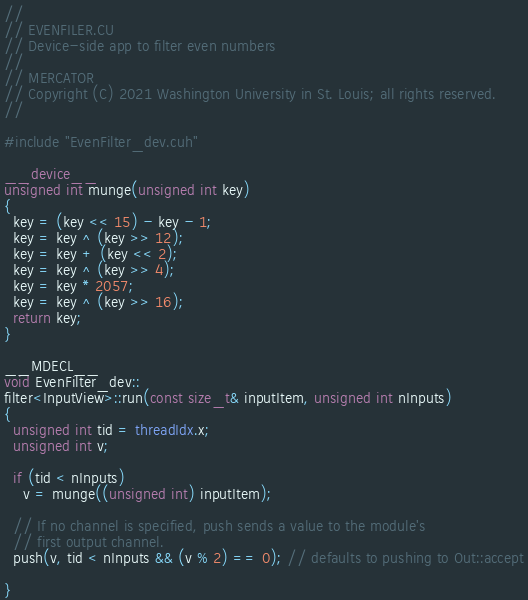Convert code to text. <code><loc_0><loc_0><loc_500><loc_500><_Cuda_>//
// EVENFILER.CU
// Device-side app to filter even numbers
//
// MERCATOR
// Copyright (C) 2021 Washington University in St. Louis; all rights reserved.
//

#include "EvenFilter_dev.cuh"

__device__
unsigned int munge(unsigned int key)
{
  key = (key << 15) - key - 1;
  key = key ^ (key >> 12);
  key = key + (key << 2);
  key = key ^ (key >> 4);
  key = key * 2057;
  key = key ^ (key >> 16);
  return key;
}

__MDECL__
void EvenFilter_dev::
filter<InputView>::run(const size_t& inputItem, unsigned int nInputs)
{
  unsigned int tid = threadIdx.x;
  unsigned int v;
  
  if (tid < nInputs)
    v = munge((unsigned int) inputItem);
  
  // If no channel is specified, push sends a value to the module's
  // first output channel.
  push(v, tid < nInputs && (v % 2) == 0); // defaults to pushing to Out::accept

}

</code> 